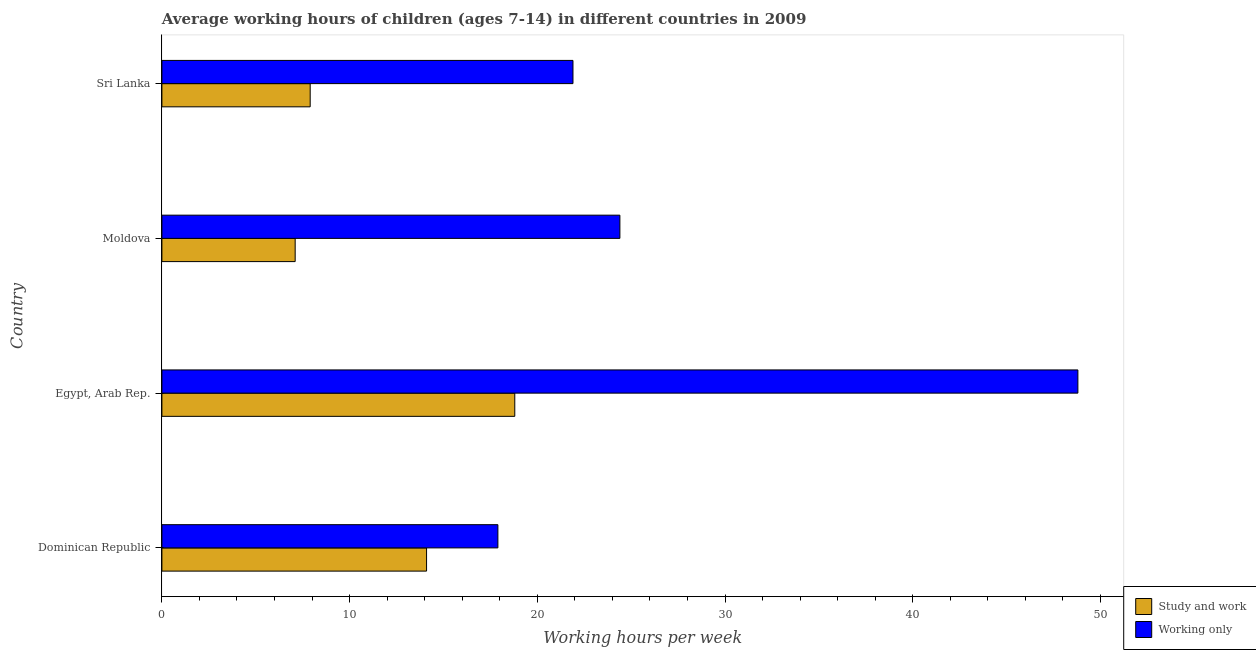How many different coloured bars are there?
Your answer should be very brief. 2. Are the number of bars per tick equal to the number of legend labels?
Ensure brevity in your answer.  Yes. How many bars are there on the 4th tick from the top?
Give a very brief answer. 2. What is the label of the 4th group of bars from the top?
Offer a very short reply. Dominican Republic. In how many cases, is the number of bars for a given country not equal to the number of legend labels?
Keep it short and to the point. 0. What is the average working hour of children involved in only work in Egypt, Arab Rep.?
Keep it short and to the point. 48.8. Across all countries, what is the maximum average working hour of children involved in study and work?
Your answer should be very brief. 18.8. In which country was the average working hour of children involved in study and work maximum?
Ensure brevity in your answer.  Egypt, Arab Rep. In which country was the average working hour of children involved in only work minimum?
Your answer should be compact. Dominican Republic. What is the total average working hour of children involved in study and work in the graph?
Your response must be concise. 47.9. What is the difference between the average working hour of children involved in only work in Egypt, Arab Rep. and the average working hour of children involved in study and work in Moldova?
Your answer should be compact. 41.7. What is the average average working hour of children involved in study and work per country?
Provide a short and direct response. 11.97. What is the difference between the average working hour of children involved in study and work and average working hour of children involved in only work in Dominican Republic?
Provide a succinct answer. -3.8. What is the ratio of the average working hour of children involved in only work in Dominican Republic to that in Sri Lanka?
Provide a succinct answer. 0.82. Is the average working hour of children involved in study and work in Dominican Republic less than that in Sri Lanka?
Provide a short and direct response. No. What is the difference between the highest and the second highest average working hour of children involved in only work?
Make the answer very short. 24.4. What is the difference between the highest and the lowest average working hour of children involved in study and work?
Offer a very short reply. 11.7. Is the sum of the average working hour of children involved in only work in Dominican Republic and Moldova greater than the maximum average working hour of children involved in study and work across all countries?
Offer a terse response. Yes. What does the 1st bar from the top in Moldova represents?
Give a very brief answer. Working only. What does the 2nd bar from the bottom in Dominican Republic represents?
Your response must be concise. Working only. How many bars are there?
Offer a terse response. 8. Are all the bars in the graph horizontal?
Your answer should be very brief. Yes. How many countries are there in the graph?
Give a very brief answer. 4. What is the difference between two consecutive major ticks on the X-axis?
Provide a short and direct response. 10. Does the graph contain grids?
Keep it short and to the point. No. How many legend labels are there?
Give a very brief answer. 2. How are the legend labels stacked?
Keep it short and to the point. Vertical. What is the title of the graph?
Provide a short and direct response. Average working hours of children (ages 7-14) in different countries in 2009. Does "International Visitors" appear as one of the legend labels in the graph?
Provide a short and direct response. No. What is the label or title of the X-axis?
Give a very brief answer. Working hours per week. What is the Working hours per week of Working only in Dominican Republic?
Offer a very short reply. 17.9. What is the Working hours per week in Study and work in Egypt, Arab Rep.?
Offer a terse response. 18.8. What is the Working hours per week of Working only in Egypt, Arab Rep.?
Keep it short and to the point. 48.8. What is the Working hours per week of Working only in Moldova?
Offer a terse response. 24.4. What is the Working hours per week of Study and work in Sri Lanka?
Your answer should be very brief. 7.9. What is the Working hours per week of Working only in Sri Lanka?
Give a very brief answer. 21.9. Across all countries, what is the maximum Working hours per week of Working only?
Make the answer very short. 48.8. Across all countries, what is the minimum Working hours per week of Working only?
Give a very brief answer. 17.9. What is the total Working hours per week in Study and work in the graph?
Offer a very short reply. 47.9. What is the total Working hours per week of Working only in the graph?
Offer a very short reply. 113. What is the difference between the Working hours per week in Working only in Dominican Republic and that in Egypt, Arab Rep.?
Your response must be concise. -30.9. What is the difference between the Working hours per week of Study and work in Dominican Republic and that in Sri Lanka?
Keep it short and to the point. 6.2. What is the difference between the Working hours per week of Study and work in Egypt, Arab Rep. and that in Moldova?
Provide a short and direct response. 11.7. What is the difference between the Working hours per week in Working only in Egypt, Arab Rep. and that in Moldova?
Give a very brief answer. 24.4. What is the difference between the Working hours per week of Working only in Egypt, Arab Rep. and that in Sri Lanka?
Your response must be concise. 26.9. What is the difference between the Working hours per week of Study and work in Moldova and that in Sri Lanka?
Keep it short and to the point. -0.8. What is the difference between the Working hours per week in Working only in Moldova and that in Sri Lanka?
Offer a very short reply. 2.5. What is the difference between the Working hours per week in Study and work in Dominican Republic and the Working hours per week in Working only in Egypt, Arab Rep.?
Make the answer very short. -34.7. What is the difference between the Working hours per week of Study and work in Dominican Republic and the Working hours per week of Working only in Sri Lanka?
Offer a very short reply. -7.8. What is the difference between the Working hours per week of Study and work in Egypt, Arab Rep. and the Working hours per week of Working only in Sri Lanka?
Give a very brief answer. -3.1. What is the difference between the Working hours per week in Study and work in Moldova and the Working hours per week in Working only in Sri Lanka?
Provide a succinct answer. -14.8. What is the average Working hours per week in Study and work per country?
Give a very brief answer. 11.97. What is the average Working hours per week of Working only per country?
Your answer should be compact. 28.25. What is the difference between the Working hours per week in Study and work and Working hours per week in Working only in Dominican Republic?
Your answer should be very brief. -3.8. What is the difference between the Working hours per week in Study and work and Working hours per week in Working only in Moldova?
Your answer should be very brief. -17.3. What is the difference between the Working hours per week in Study and work and Working hours per week in Working only in Sri Lanka?
Keep it short and to the point. -14. What is the ratio of the Working hours per week in Study and work in Dominican Republic to that in Egypt, Arab Rep.?
Your answer should be compact. 0.75. What is the ratio of the Working hours per week in Working only in Dominican Republic to that in Egypt, Arab Rep.?
Your answer should be very brief. 0.37. What is the ratio of the Working hours per week of Study and work in Dominican Republic to that in Moldova?
Provide a succinct answer. 1.99. What is the ratio of the Working hours per week in Working only in Dominican Republic to that in Moldova?
Provide a short and direct response. 0.73. What is the ratio of the Working hours per week in Study and work in Dominican Republic to that in Sri Lanka?
Your answer should be very brief. 1.78. What is the ratio of the Working hours per week in Working only in Dominican Republic to that in Sri Lanka?
Give a very brief answer. 0.82. What is the ratio of the Working hours per week of Study and work in Egypt, Arab Rep. to that in Moldova?
Ensure brevity in your answer.  2.65. What is the ratio of the Working hours per week in Working only in Egypt, Arab Rep. to that in Moldova?
Your response must be concise. 2. What is the ratio of the Working hours per week of Study and work in Egypt, Arab Rep. to that in Sri Lanka?
Your answer should be compact. 2.38. What is the ratio of the Working hours per week of Working only in Egypt, Arab Rep. to that in Sri Lanka?
Offer a terse response. 2.23. What is the ratio of the Working hours per week of Study and work in Moldova to that in Sri Lanka?
Your answer should be very brief. 0.9. What is the ratio of the Working hours per week of Working only in Moldova to that in Sri Lanka?
Offer a very short reply. 1.11. What is the difference between the highest and the second highest Working hours per week in Working only?
Provide a short and direct response. 24.4. What is the difference between the highest and the lowest Working hours per week of Working only?
Offer a terse response. 30.9. 